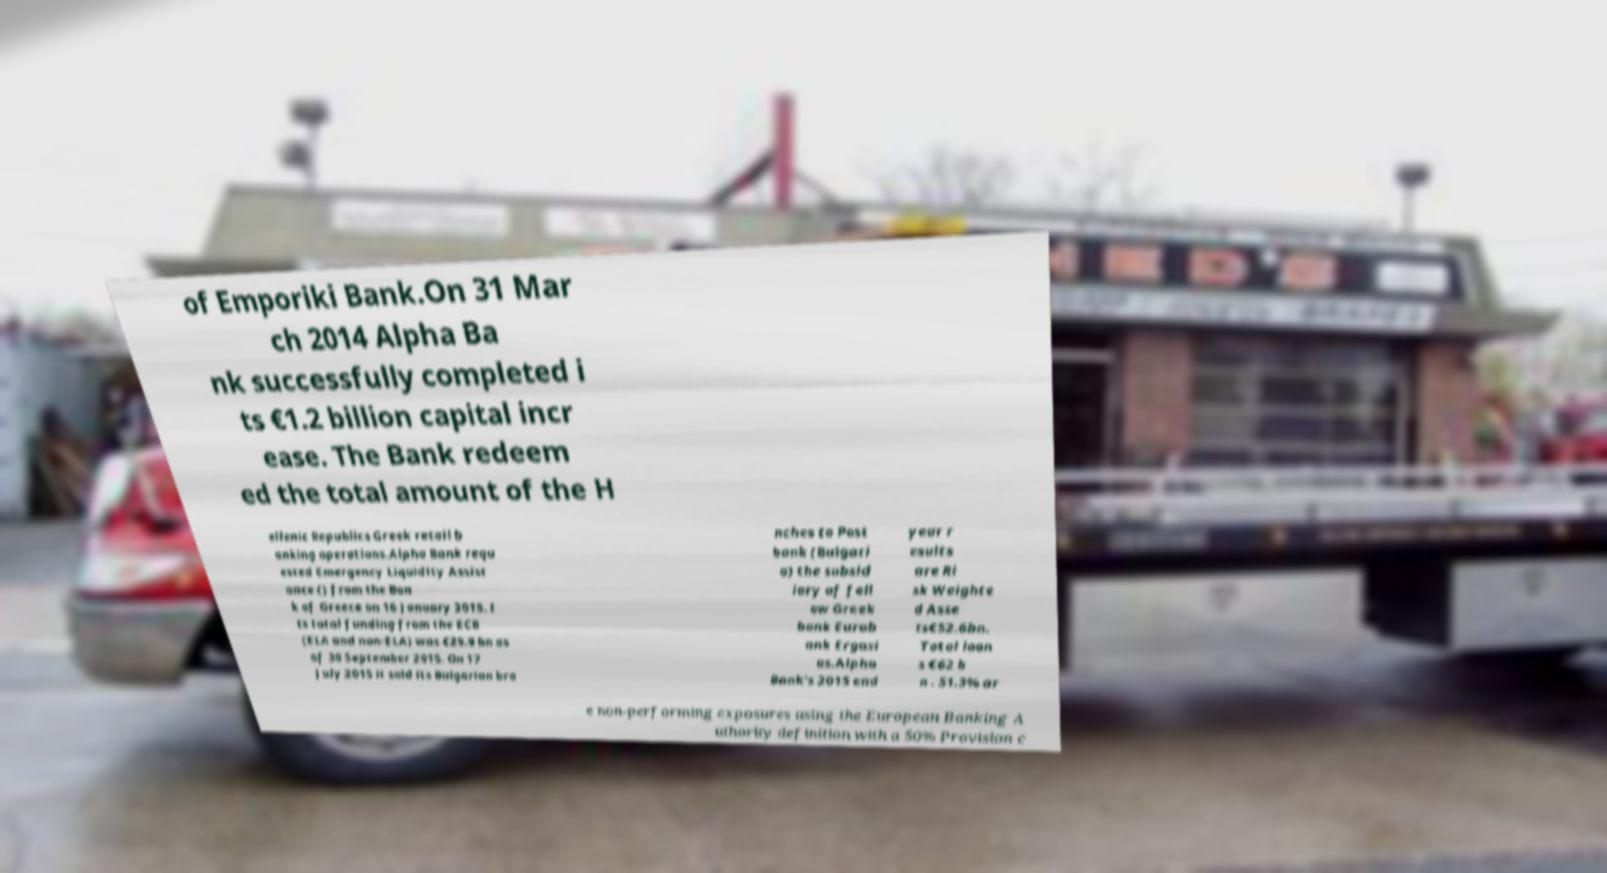What messages or text are displayed in this image? I need them in a readable, typed format. of Emporiki Bank.On 31 Mar ch 2014 Alpha Ba nk successfully completed i ts €1.2 billion capital incr ease. The Bank redeem ed the total amount of the H ellenic Republics Greek retail b anking operations.Alpha Bank requ ested Emergency Liquidity Assist ance () from the Ban k of Greece on 16 January 2015. I ts total funding from the ECB (ELA and non-ELA) was €29.9 bn as of 30 September 2015. On 17 July 2015 it sold its Bulgarian bra nches to Post bank (Bulgari a) the subsid iary of fell ow Greek bank Eurob ank Ergasi as.Alpha Bank's 2015 end year r esults are Ri sk Weighte d Asse ts€52.6bn. Total loan s €62 b n . 51.3% ar e non-performing exposures using the European Banking A uthority definition with a 50% Provision c 